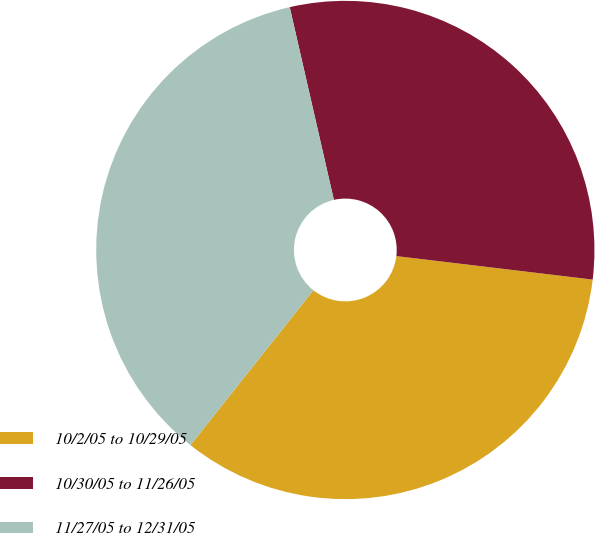<chart> <loc_0><loc_0><loc_500><loc_500><pie_chart><fcel>10/2/05 to 10/29/05<fcel>10/30/05 to 11/26/05<fcel>11/27/05 to 12/31/05<nl><fcel>33.78%<fcel>30.48%<fcel>35.74%<nl></chart> 